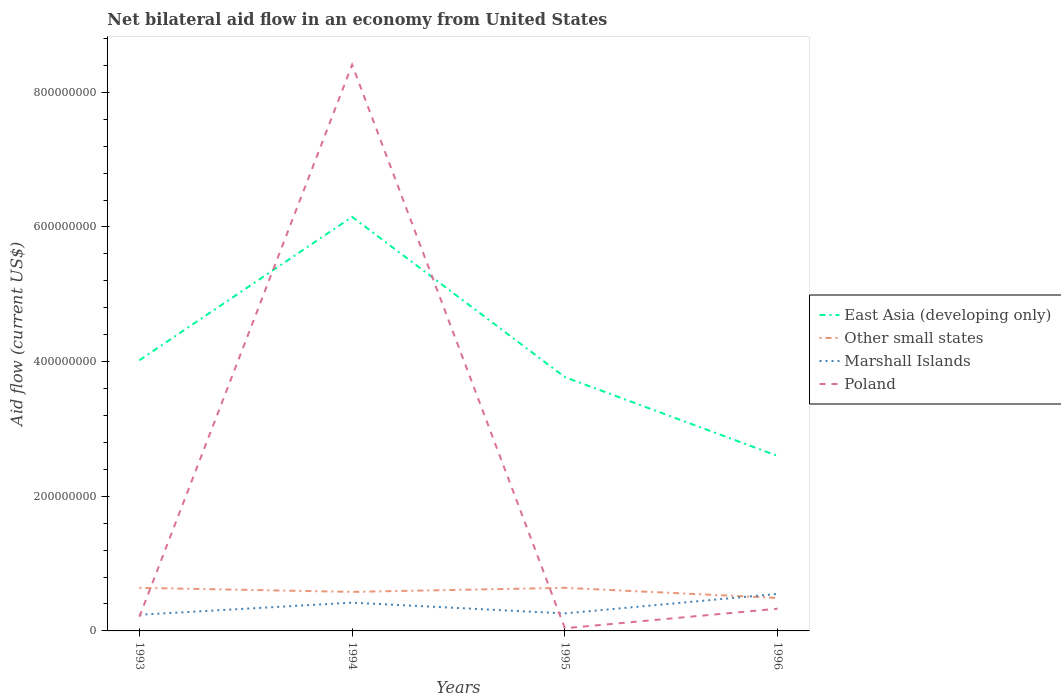Is the number of lines equal to the number of legend labels?
Your response must be concise. Yes. Across all years, what is the maximum net bilateral aid flow in Marshall Islands?
Offer a terse response. 2.40e+07. What is the total net bilateral aid flow in Other small states in the graph?
Your answer should be compact. -6.00e+06. What is the difference between the highest and the second highest net bilateral aid flow in East Asia (developing only)?
Offer a terse response. 3.55e+08. What is the difference between the highest and the lowest net bilateral aid flow in Poland?
Offer a very short reply. 1. Is the net bilateral aid flow in Marshall Islands strictly greater than the net bilateral aid flow in Other small states over the years?
Provide a short and direct response. No. What is the difference between two consecutive major ticks on the Y-axis?
Make the answer very short. 2.00e+08. Does the graph contain grids?
Offer a very short reply. No. Where does the legend appear in the graph?
Give a very brief answer. Center right. How many legend labels are there?
Your response must be concise. 4. What is the title of the graph?
Your response must be concise. Net bilateral aid flow in an economy from United States. Does "Togo" appear as one of the legend labels in the graph?
Your answer should be very brief. No. What is the label or title of the X-axis?
Your answer should be very brief. Years. What is the Aid flow (current US$) of East Asia (developing only) in 1993?
Offer a terse response. 4.02e+08. What is the Aid flow (current US$) in Other small states in 1993?
Give a very brief answer. 6.40e+07. What is the Aid flow (current US$) of Marshall Islands in 1993?
Make the answer very short. 2.40e+07. What is the Aid flow (current US$) in Poland in 1993?
Provide a succinct answer. 2.10e+07. What is the Aid flow (current US$) in East Asia (developing only) in 1994?
Give a very brief answer. 6.15e+08. What is the Aid flow (current US$) of Other small states in 1994?
Provide a short and direct response. 5.80e+07. What is the Aid flow (current US$) in Marshall Islands in 1994?
Keep it short and to the point. 4.20e+07. What is the Aid flow (current US$) of Poland in 1994?
Ensure brevity in your answer.  8.41e+08. What is the Aid flow (current US$) of East Asia (developing only) in 1995?
Keep it short and to the point. 3.77e+08. What is the Aid flow (current US$) in Other small states in 1995?
Offer a very short reply. 6.40e+07. What is the Aid flow (current US$) of Marshall Islands in 1995?
Your answer should be compact. 2.60e+07. What is the Aid flow (current US$) of Poland in 1995?
Your answer should be compact. 4.00e+06. What is the Aid flow (current US$) in East Asia (developing only) in 1996?
Make the answer very short. 2.60e+08. What is the Aid flow (current US$) of Other small states in 1996?
Provide a succinct answer. 4.90e+07. What is the Aid flow (current US$) in Marshall Islands in 1996?
Your response must be concise. 5.50e+07. What is the Aid flow (current US$) in Poland in 1996?
Keep it short and to the point. 3.30e+07. Across all years, what is the maximum Aid flow (current US$) in East Asia (developing only)?
Ensure brevity in your answer.  6.15e+08. Across all years, what is the maximum Aid flow (current US$) of Other small states?
Give a very brief answer. 6.40e+07. Across all years, what is the maximum Aid flow (current US$) in Marshall Islands?
Your response must be concise. 5.50e+07. Across all years, what is the maximum Aid flow (current US$) in Poland?
Provide a succinct answer. 8.41e+08. Across all years, what is the minimum Aid flow (current US$) of East Asia (developing only)?
Offer a very short reply. 2.60e+08. Across all years, what is the minimum Aid flow (current US$) of Other small states?
Give a very brief answer. 4.90e+07. Across all years, what is the minimum Aid flow (current US$) of Marshall Islands?
Keep it short and to the point. 2.40e+07. What is the total Aid flow (current US$) in East Asia (developing only) in the graph?
Provide a short and direct response. 1.65e+09. What is the total Aid flow (current US$) of Other small states in the graph?
Offer a terse response. 2.35e+08. What is the total Aid flow (current US$) of Marshall Islands in the graph?
Offer a terse response. 1.47e+08. What is the total Aid flow (current US$) of Poland in the graph?
Your answer should be compact. 8.99e+08. What is the difference between the Aid flow (current US$) of East Asia (developing only) in 1993 and that in 1994?
Provide a succinct answer. -2.13e+08. What is the difference between the Aid flow (current US$) in Other small states in 1993 and that in 1994?
Your response must be concise. 6.00e+06. What is the difference between the Aid flow (current US$) in Marshall Islands in 1993 and that in 1994?
Provide a succinct answer. -1.80e+07. What is the difference between the Aid flow (current US$) of Poland in 1993 and that in 1994?
Make the answer very short. -8.20e+08. What is the difference between the Aid flow (current US$) in East Asia (developing only) in 1993 and that in 1995?
Give a very brief answer. 2.50e+07. What is the difference between the Aid flow (current US$) in Poland in 1993 and that in 1995?
Provide a short and direct response. 1.70e+07. What is the difference between the Aid flow (current US$) of East Asia (developing only) in 1993 and that in 1996?
Your answer should be compact. 1.42e+08. What is the difference between the Aid flow (current US$) of Other small states in 1993 and that in 1996?
Ensure brevity in your answer.  1.50e+07. What is the difference between the Aid flow (current US$) of Marshall Islands in 1993 and that in 1996?
Provide a short and direct response. -3.10e+07. What is the difference between the Aid flow (current US$) in Poland in 1993 and that in 1996?
Provide a short and direct response. -1.20e+07. What is the difference between the Aid flow (current US$) in East Asia (developing only) in 1994 and that in 1995?
Your response must be concise. 2.38e+08. What is the difference between the Aid flow (current US$) of Other small states in 1994 and that in 1995?
Provide a short and direct response. -6.00e+06. What is the difference between the Aid flow (current US$) in Marshall Islands in 1994 and that in 1995?
Ensure brevity in your answer.  1.60e+07. What is the difference between the Aid flow (current US$) of Poland in 1994 and that in 1995?
Your answer should be compact. 8.37e+08. What is the difference between the Aid flow (current US$) in East Asia (developing only) in 1994 and that in 1996?
Offer a very short reply. 3.55e+08. What is the difference between the Aid flow (current US$) of Other small states in 1994 and that in 1996?
Offer a very short reply. 9.00e+06. What is the difference between the Aid flow (current US$) in Marshall Islands in 1994 and that in 1996?
Keep it short and to the point. -1.30e+07. What is the difference between the Aid flow (current US$) in Poland in 1994 and that in 1996?
Ensure brevity in your answer.  8.08e+08. What is the difference between the Aid flow (current US$) of East Asia (developing only) in 1995 and that in 1996?
Your response must be concise. 1.17e+08. What is the difference between the Aid flow (current US$) of Other small states in 1995 and that in 1996?
Offer a very short reply. 1.50e+07. What is the difference between the Aid flow (current US$) of Marshall Islands in 1995 and that in 1996?
Provide a succinct answer. -2.90e+07. What is the difference between the Aid flow (current US$) in Poland in 1995 and that in 1996?
Give a very brief answer. -2.90e+07. What is the difference between the Aid flow (current US$) of East Asia (developing only) in 1993 and the Aid flow (current US$) of Other small states in 1994?
Keep it short and to the point. 3.44e+08. What is the difference between the Aid flow (current US$) of East Asia (developing only) in 1993 and the Aid flow (current US$) of Marshall Islands in 1994?
Keep it short and to the point. 3.60e+08. What is the difference between the Aid flow (current US$) in East Asia (developing only) in 1993 and the Aid flow (current US$) in Poland in 1994?
Provide a short and direct response. -4.39e+08. What is the difference between the Aid flow (current US$) of Other small states in 1993 and the Aid flow (current US$) of Marshall Islands in 1994?
Provide a short and direct response. 2.20e+07. What is the difference between the Aid flow (current US$) of Other small states in 1993 and the Aid flow (current US$) of Poland in 1994?
Keep it short and to the point. -7.77e+08. What is the difference between the Aid flow (current US$) of Marshall Islands in 1993 and the Aid flow (current US$) of Poland in 1994?
Give a very brief answer. -8.17e+08. What is the difference between the Aid flow (current US$) in East Asia (developing only) in 1993 and the Aid flow (current US$) in Other small states in 1995?
Offer a very short reply. 3.38e+08. What is the difference between the Aid flow (current US$) in East Asia (developing only) in 1993 and the Aid flow (current US$) in Marshall Islands in 1995?
Your answer should be very brief. 3.76e+08. What is the difference between the Aid flow (current US$) in East Asia (developing only) in 1993 and the Aid flow (current US$) in Poland in 1995?
Your answer should be compact. 3.98e+08. What is the difference between the Aid flow (current US$) in Other small states in 1993 and the Aid flow (current US$) in Marshall Islands in 1995?
Ensure brevity in your answer.  3.80e+07. What is the difference between the Aid flow (current US$) of Other small states in 1993 and the Aid flow (current US$) of Poland in 1995?
Provide a short and direct response. 6.00e+07. What is the difference between the Aid flow (current US$) in East Asia (developing only) in 1993 and the Aid flow (current US$) in Other small states in 1996?
Keep it short and to the point. 3.53e+08. What is the difference between the Aid flow (current US$) of East Asia (developing only) in 1993 and the Aid flow (current US$) of Marshall Islands in 1996?
Provide a short and direct response. 3.47e+08. What is the difference between the Aid flow (current US$) in East Asia (developing only) in 1993 and the Aid flow (current US$) in Poland in 1996?
Your answer should be compact. 3.69e+08. What is the difference between the Aid flow (current US$) in Other small states in 1993 and the Aid flow (current US$) in Marshall Islands in 1996?
Your answer should be compact. 9.00e+06. What is the difference between the Aid flow (current US$) of Other small states in 1993 and the Aid flow (current US$) of Poland in 1996?
Your response must be concise. 3.10e+07. What is the difference between the Aid flow (current US$) in Marshall Islands in 1993 and the Aid flow (current US$) in Poland in 1996?
Keep it short and to the point. -9.00e+06. What is the difference between the Aid flow (current US$) in East Asia (developing only) in 1994 and the Aid flow (current US$) in Other small states in 1995?
Make the answer very short. 5.51e+08. What is the difference between the Aid flow (current US$) in East Asia (developing only) in 1994 and the Aid flow (current US$) in Marshall Islands in 1995?
Provide a short and direct response. 5.89e+08. What is the difference between the Aid flow (current US$) of East Asia (developing only) in 1994 and the Aid flow (current US$) of Poland in 1995?
Offer a terse response. 6.11e+08. What is the difference between the Aid flow (current US$) of Other small states in 1994 and the Aid flow (current US$) of Marshall Islands in 1995?
Give a very brief answer. 3.20e+07. What is the difference between the Aid flow (current US$) in Other small states in 1994 and the Aid flow (current US$) in Poland in 1995?
Provide a succinct answer. 5.40e+07. What is the difference between the Aid flow (current US$) in Marshall Islands in 1994 and the Aid flow (current US$) in Poland in 1995?
Offer a terse response. 3.80e+07. What is the difference between the Aid flow (current US$) of East Asia (developing only) in 1994 and the Aid flow (current US$) of Other small states in 1996?
Ensure brevity in your answer.  5.66e+08. What is the difference between the Aid flow (current US$) in East Asia (developing only) in 1994 and the Aid flow (current US$) in Marshall Islands in 1996?
Your answer should be very brief. 5.60e+08. What is the difference between the Aid flow (current US$) in East Asia (developing only) in 1994 and the Aid flow (current US$) in Poland in 1996?
Ensure brevity in your answer.  5.82e+08. What is the difference between the Aid flow (current US$) in Other small states in 1994 and the Aid flow (current US$) in Poland in 1996?
Offer a terse response. 2.50e+07. What is the difference between the Aid flow (current US$) in Marshall Islands in 1994 and the Aid flow (current US$) in Poland in 1996?
Keep it short and to the point. 9.00e+06. What is the difference between the Aid flow (current US$) in East Asia (developing only) in 1995 and the Aid flow (current US$) in Other small states in 1996?
Your response must be concise. 3.28e+08. What is the difference between the Aid flow (current US$) of East Asia (developing only) in 1995 and the Aid flow (current US$) of Marshall Islands in 1996?
Your answer should be very brief. 3.22e+08. What is the difference between the Aid flow (current US$) in East Asia (developing only) in 1995 and the Aid flow (current US$) in Poland in 1996?
Ensure brevity in your answer.  3.44e+08. What is the difference between the Aid flow (current US$) in Other small states in 1995 and the Aid flow (current US$) in Marshall Islands in 1996?
Give a very brief answer. 9.00e+06. What is the difference between the Aid flow (current US$) in Other small states in 1995 and the Aid flow (current US$) in Poland in 1996?
Make the answer very short. 3.10e+07. What is the difference between the Aid flow (current US$) in Marshall Islands in 1995 and the Aid flow (current US$) in Poland in 1996?
Ensure brevity in your answer.  -7.00e+06. What is the average Aid flow (current US$) in East Asia (developing only) per year?
Your answer should be very brief. 4.14e+08. What is the average Aid flow (current US$) in Other small states per year?
Keep it short and to the point. 5.88e+07. What is the average Aid flow (current US$) in Marshall Islands per year?
Make the answer very short. 3.68e+07. What is the average Aid flow (current US$) of Poland per year?
Keep it short and to the point. 2.25e+08. In the year 1993, what is the difference between the Aid flow (current US$) of East Asia (developing only) and Aid flow (current US$) of Other small states?
Keep it short and to the point. 3.38e+08. In the year 1993, what is the difference between the Aid flow (current US$) in East Asia (developing only) and Aid flow (current US$) in Marshall Islands?
Your response must be concise. 3.78e+08. In the year 1993, what is the difference between the Aid flow (current US$) of East Asia (developing only) and Aid flow (current US$) of Poland?
Keep it short and to the point. 3.81e+08. In the year 1993, what is the difference between the Aid flow (current US$) of Other small states and Aid flow (current US$) of Marshall Islands?
Your answer should be compact. 4.00e+07. In the year 1993, what is the difference between the Aid flow (current US$) in Other small states and Aid flow (current US$) in Poland?
Ensure brevity in your answer.  4.30e+07. In the year 1994, what is the difference between the Aid flow (current US$) in East Asia (developing only) and Aid flow (current US$) in Other small states?
Offer a terse response. 5.57e+08. In the year 1994, what is the difference between the Aid flow (current US$) in East Asia (developing only) and Aid flow (current US$) in Marshall Islands?
Provide a short and direct response. 5.73e+08. In the year 1994, what is the difference between the Aid flow (current US$) of East Asia (developing only) and Aid flow (current US$) of Poland?
Your answer should be very brief. -2.26e+08. In the year 1994, what is the difference between the Aid flow (current US$) of Other small states and Aid flow (current US$) of Marshall Islands?
Offer a very short reply. 1.60e+07. In the year 1994, what is the difference between the Aid flow (current US$) of Other small states and Aid flow (current US$) of Poland?
Provide a short and direct response. -7.83e+08. In the year 1994, what is the difference between the Aid flow (current US$) in Marshall Islands and Aid flow (current US$) in Poland?
Keep it short and to the point. -7.99e+08. In the year 1995, what is the difference between the Aid flow (current US$) in East Asia (developing only) and Aid flow (current US$) in Other small states?
Ensure brevity in your answer.  3.13e+08. In the year 1995, what is the difference between the Aid flow (current US$) in East Asia (developing only) and Aid flow (current US$) in Marshall Islands?
Ensure brevity in your answer.  3.51e+08. In the year 1995, what is the difference between the Aid flow (current US$) of East Asia (developing only) and Aid flow (current US$) of Poland?
Offer a terse response. 3.73e+08. In the year 1995, what is the difference between the Aid flow (current US$) of Other small states and Aid flow (current US$) of Marshall Islands?
Offer a very short reply. 3.80e+07. In the year 1995, what is the difference between the Aid flow (current US$) in Other small states and Aid flow (current US$) in Poland?
Keep it short and to the point. 6.00e+07. In the year 1995, what is the difference between the Aid flow (current US$) of Marshall Islands and Aid flow (current US$) of Poland?
Your response must be concise. 2.20e+07. In the year 1996, what is the difference between the Aid flow (current US$) of East Asia (developing only) and Aid flow (current US$) of Other small states?
Ensure brevity in your answer.  2.11e+08. In the year 1996, what is the difference between the Aid flow (current US$) of East Asia (developing only) and Aid flow (current US$) of Marshall Islands?
Offer a very short reply. 2.05e+08. In the year 1996, what is the difference between the Aid flow (current US$) in East Asia (developing only) and Aid flow (current US$) in Poland?
Offer a terse response. 2.27e+08. In the year 1996, what is the difference between the Aid flow (current US$) in Other small states and Aid flow (current US$) in Marshall Islands?
Ensure brevity in your answer.  -6.00e+06. In the year 1996, what is the difference between the Aid flow (current US$) in Other small states and Aid flow (current US$) in Poland?
Provide a short and direct response. 1.60e+07. In the year 1996, what is the difference between the Aid flow (current US$) of Marshall Islands and Aid flow (current US$) of Poland?
Your response must be concise. 2.20e+07. What is the ratio of the Aid flow (current US$) in East Asia (developing only) in 1993 to that in 1994?
Your answer should be very brief. 0.65. What is the ratio of the Aid flow (current US$) in Other small states in 1993 to that in 1994?
Your response must be concise. 1.1. What is the ratio of the Aid flow (current US$) of Marshall Islands in 1993 to that in 1994?
Give a very brief answer. 0.57. What is the ratio of the Aid flow (current US$) in Poland in 1993 to that in 1994?
Your answer should be very brief. 0.03. What is the ratio of the Aid flow (current US$) of East Asia (developing only) in 1993 to that in 1995?
Ensure brevity in your answer.  1.07. What is the ratio of the Aid flow (current US$) in Marshall Islands in 1993 to that in 1995?
Make the answer very short. 0.92. What is the ratio of the Aid flow (current US$) in Poland in 1993 to that in 1995?
Provide a succinct answer. 5.25. What is the ratio of the Aid flow (current US$) of East Asia (developing only) in 1993 to that in 1996?
Give a very brief answer. 1.55. What is the ratio of the Aid flow (current US$) of Other small states in 1993 to that in 1996?
Offer a very short reply. 1.31. What is the ratio of the Aid flow (current US$) in Marshall Islands in 1993 to that in 1996?
Ensure brevity in your answer.  0.44. What is the ratio of the Aid flow (current US$) of Poland in 1993 to that in 1996?
Keep it short and to the point. 0.64. What is the ratio of the Aid flow (current US$) in East Asia (developing only) in 1994 to that in 1995?
Keep it short and to the point. 1.63. What is the ratio of the Aid flow (current US$) in Other small states in 1994 to that in 1995?
Your answer should be compact. 0.91. What is the ratio of the Aid flow (current US$) of Marshall Islands in 1994 to that in 1995?
Make the answer very short. 1.62. What is the ratio of the Aid flow (current US$) of Poland in 1994 to that in 1995?
Provide a short and direct response. 210.25. What is the ratio of the Aid flow (current US$) in East Asia (developing only) in 1994 to that in 1996?
Offer a terse response. 2.37. What is the ratio of the Aid flow (current US$) of Other small states in 1994 to that in 1996?
Your response must be concise. 1.18. What is the ratio of the Aid flow (current US$) of Marshall Islands in 1994 to that in 1996?
Make the answer very short. 0.76. What is the ratio of the Aid flow (current US$) of Poland in 1994 to that in 1996?
Ensure brevity in your answer.  25.48. What is the ratio of the Aid flow (current US$) of East Asia (developing only) in 1995 to that in 1996?
Provide a short and direct response. 1.45. What is the ratio of the Aid flow (current US$) of Other small states in 1995 to that in 1996?
Ensure brevity in your answer.  1.31. What is the ratio of the Aid flow (current US$) in Marshall Islands in 1995 to that in 1996?
Keep it short and to the point. 0.47. What is the ratio of the Aid flow (current US$) of Poland in 1995 to that in 1996?
Your answer should be very brief. 0.12. What is the difference between the highest and the second highest Aid flow (current US$) in East Asia (developing only)?
Your response must be concise. 2.13e+08. What is the difference between the highest and the second highest Aid flow (current US$) in Marshall Islands?
Ensure brevity in your answer.  1.30e+07. What is the difference between the highest and the second highest Aid flow (current US$) in Poland?
Make the answer very short. 8.08e+08. What is the difference between the highest and the lowest Aid flow (current US$) of East Asia (developing only)?
Your answer should be compact. 3.55e+08. What is the difference between the highest and the lowest Aid flow (current US$) in Other small states?
Offer a very short reply. 1.50e+07. What is the difference between the highest and the lowest Aid flow (current US$) of Marshall Islands?
Ensure brevity in your answer.  3.10e+07. What is the difference between the highest and the lowest Aid flow (current US$) of Poland?
Give a very brief answer. 8.37e+08. 